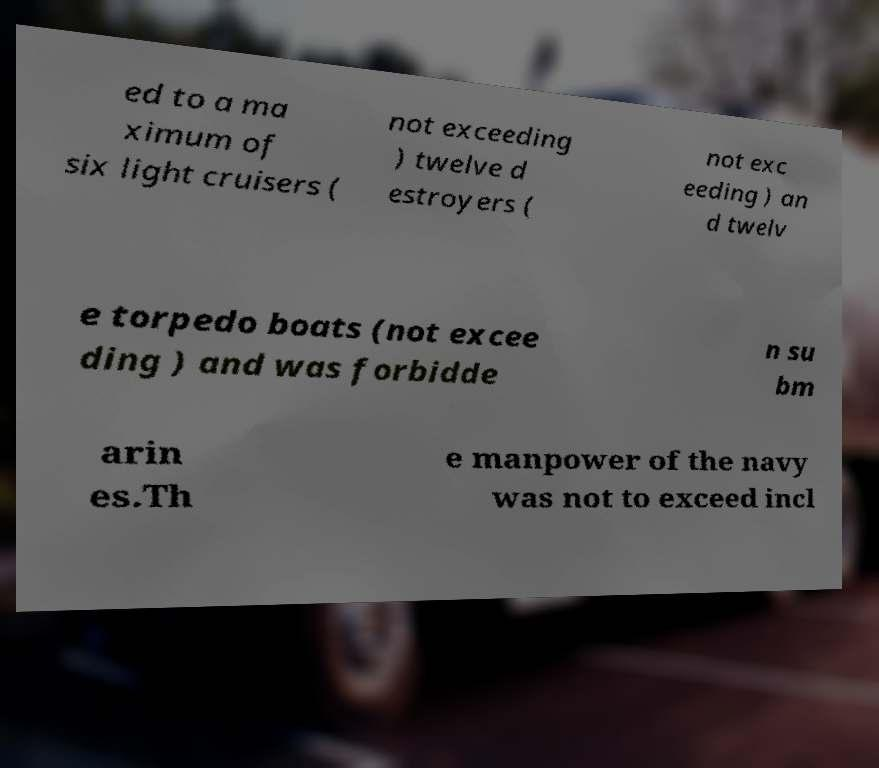Can you read and provide the text displayed in the image?This photo seems to have some interesting text. Can you extract and type it out for me? ed to a ma ximum of six light cruisers ( not exceeding ) twelve d estroyers ( not exc eeding ) an d twelv e torpedo boats (not excee ding ) and was forbidde n su bm arin es.Th e manpower of the navy was not to exceed incl 